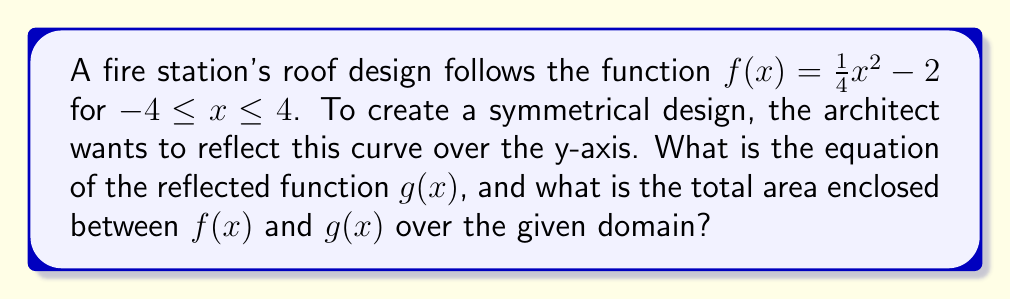Can you answer this question? 1) To reflect $f(x)$ over the y-axis, we replace $x$ with $-x$ in the original function:

   $g(x) = f(-x) = \frac{1}{4}(-x)^2 - 2 = \frac{1}{4}x^2 - 2$

2) We see that $g(x) = f(x)$, which means the function is symmetrical about the y-axis.

3) To find the area between $f(x)$ and $g(x)$, we need to calculate:

   $\int_{-4}^4 [f(x) - g(x)] dx$

   However, since $f(x) = g(x)$, this integral equals zero.

4) To find the actual enclosed area, we need to calculate twice the area under $f(x)$ from 0 to 4:

   Area = $2 \int_0^4 [\frac{1}{4}x^2 - 2] dx$

5) Integrating:

   $2 [\frac{1}{12}x^3 - 2x]_0^4$

6) Evaluating:

   $2 [(\frac{64}{12} - 8) - (0 - 0)] = 2 [\frac{16}{3} - 8] = 2 [\frac{16-24}{3}] = -\frac{16}{3}$

7) The negative sign indicates area below the x-axis. The total enclosed area is the absolute value:

   $|\frac{16}{3}| = \frac{16}{3}$
Answer: $g(x) = \frac{1}{4}x^2 - 2$; Area = $\frac{16}{3}$ square units 